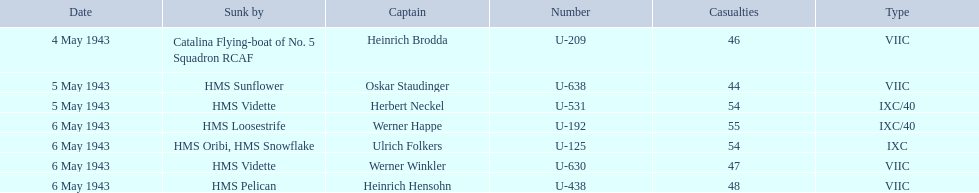Who are the captains of the u boats? Heinrich Brodda, Oskar Staudinger, Herbert Neckel, Werner Happe, Ulrich Folkers, Werner Winkler, Heinrich Hensohn. What are the dates the u boat captains were lost? 4 May 1943, 5 May 1943, 5 May 1943, 6 May 1943, 6 May 1943, 6 May 1943, 6 May 1943. Of these, which were lost on may 5? Oskar Staudinger, Herbert Neckel. Other than oskar staudinger, who else was lost on this day? Herbert Neckel. 